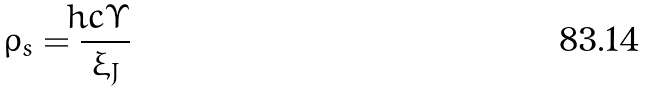<formula> <loc_0><loc_0><loc_500><loc_500>\rho _ { s } = \frac { \hbar { c } \Upsilon } { \xi _ { J } }</formula> 